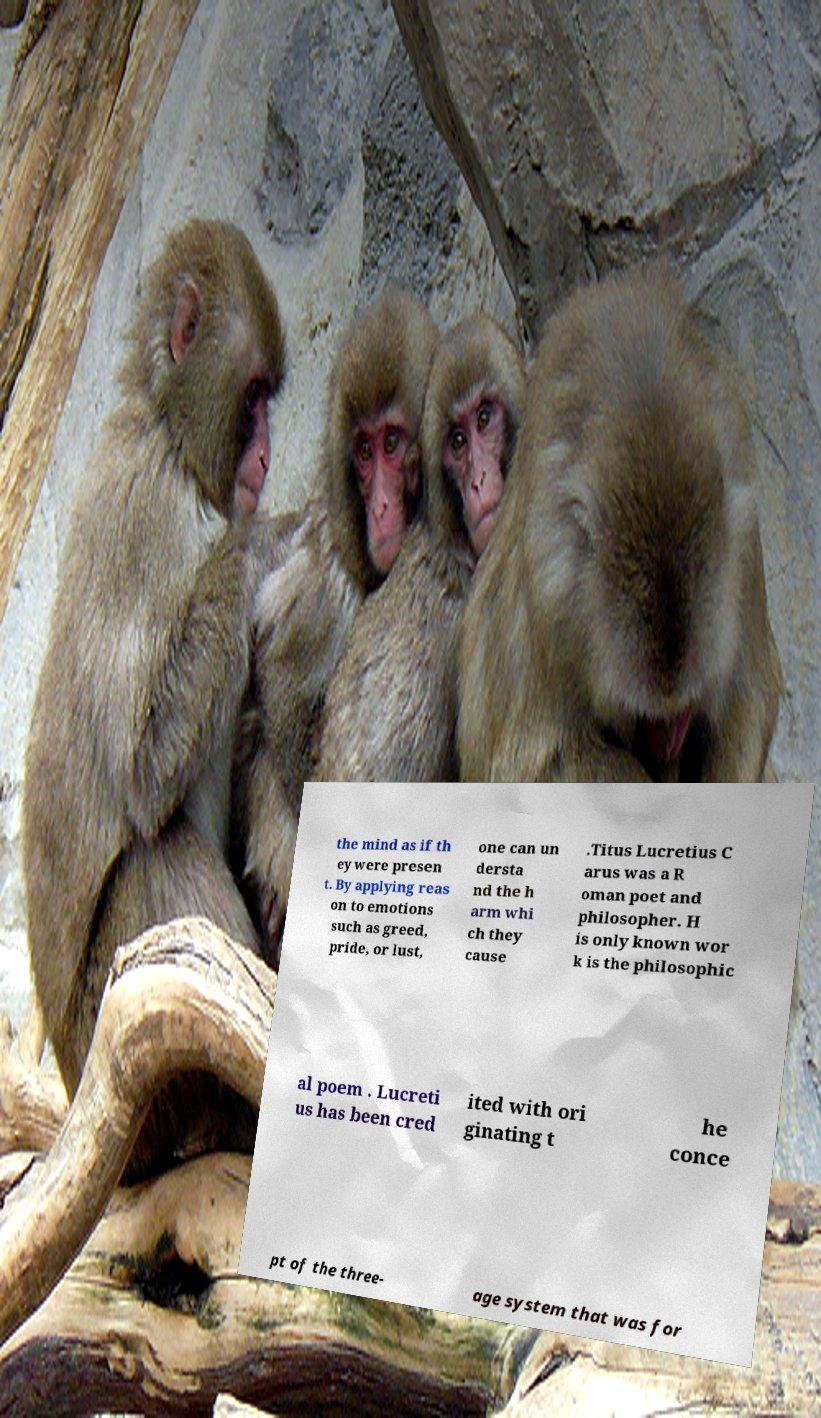I need the written content from this picture converted into text. Can you do that? the mind as if th ey were presen t. By applying reas on to emotions such as greed, pride, or lust, one can un dersta nd the h arm whi ch they cause .Titus Lucretius C arus was a R oman poet and philosopher. H is only known wor k is the philosophic al poem . Lucreti us has been cred ited with ori ginating t he conce pt of the three- age system that was for 